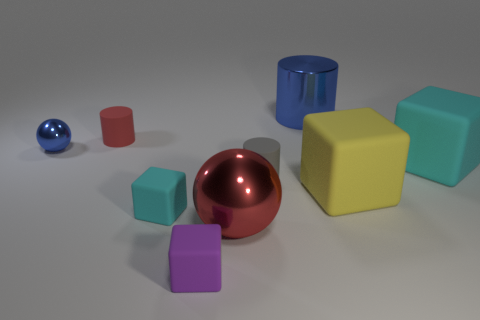What is the shape of the object that is the same color as the large shiny sphere?
Your answer should be compact. Cylinder. What is the cylinder that is both on the right side of the red cylinder and behind the tiny metal thing made of?
Offer a terse response. Metal. Is the size of the blue cylinder the same as the gray thing?
Provide a short and direct response. No. There is a yellow block that is on the right side of the shiny object that is in front of the gray cylinder; what size is it?
Keep it short and to the point. Large. What number of large things are in front of the big cyan cube and to the left of the yellow matte thing?
Make the answer very short. 1. There is a metal sphere that is in front of the thing on the right side of the large yellow block; is there a block behind it?
Offer a terse response. Yes. There is a purple object that is the same size as the red cylinder; what is its shape?
Ensure brevity in your answer.  Cube. Is there a small metallic sphere that has the same color as the metallic cylinder?
Your answer should be very brief. Yes. Do the gray matte thing and the large red metal object have the same shape?
Keep it short and to the point. No. What number of tiny objects are brown things or cylinders?
Your answer should be compact. 2. 